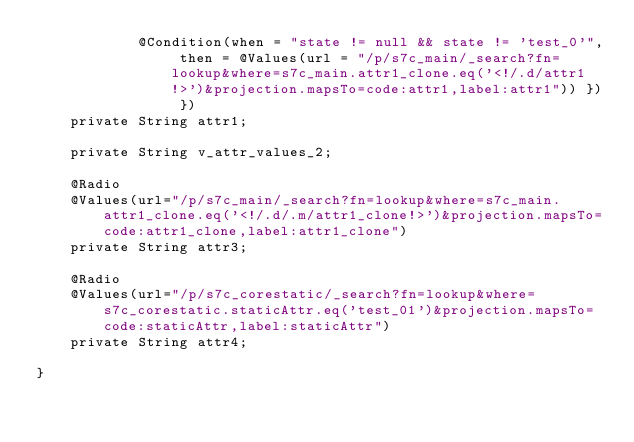<code> <loc_0><loc_0><loc_500><loc_500><_Java_>			@Condition(when = "state != null && state != 'test_0'", then = @Values(url = "/p/s7c_main/_search?fn=lookup&where=s7c_main.attr1_clone.eq('<!/.d/attr1!>')&projection.mapsTo=code:attr1,label:attr1")) }) })
	private String attr1;
	
	private String v_attr_values_2;
	
	@Radio
	@Values(url="/p/s7c_main/_search?fn=lookup&where=s7c_main.attr1_clone.eq('<!/.d/.m/attr1_clone!>')&projection.mapsTo=code:attr1_clone,label:attr1_clone")
	private String attr3;
	
	@Radio
	@Values(url="/p/s7c_corestatic/_search?fn=lookup&where=s7c_corestatic.staticAttr.eq('test_01')&projection.mapsTo=code:staticAttr,label:staticAttr")
	private String attr4;
	
}
</code> 